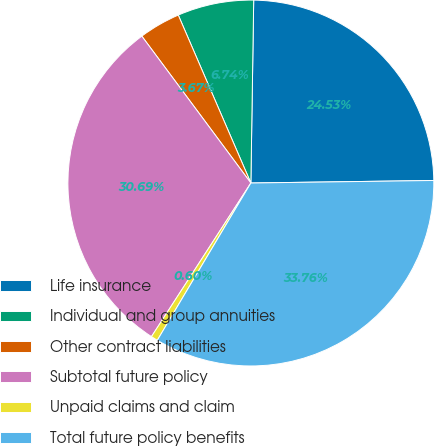Convert chart to OTSL. <chart><loc_0><loc_0><loc_500><loc_500><pie_chart><fcel>Life insurance<fcel>Individual and group annuities<fcel>Other contract liabilities<fcel>Subtotal future policy<fcel>Unpaid claims and claim<fcel>Total future policy benefits<nl><fcel>24.53%<fcel>6.74%<fcel>3.67%<fcel>30.69%<fcel>0.6%<fcel>33.76%<nl></chart> 